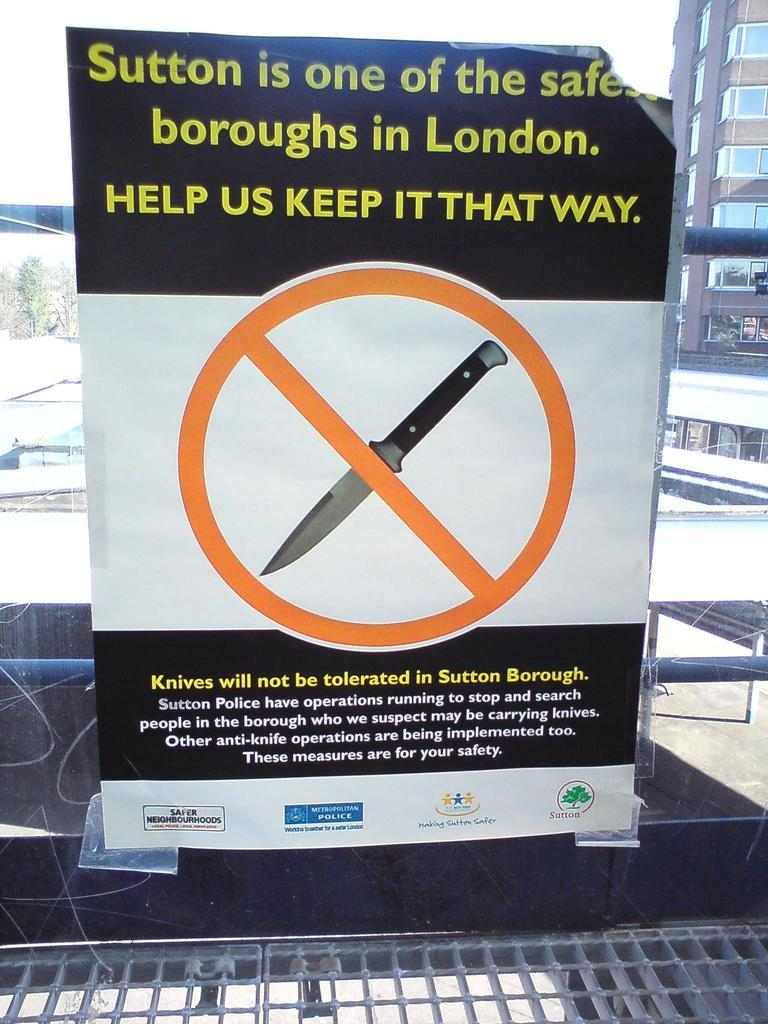<image>
Provide a brief description of the given image. Sign on a window that says that Knives will not be tolerated in Sutton Borough. 